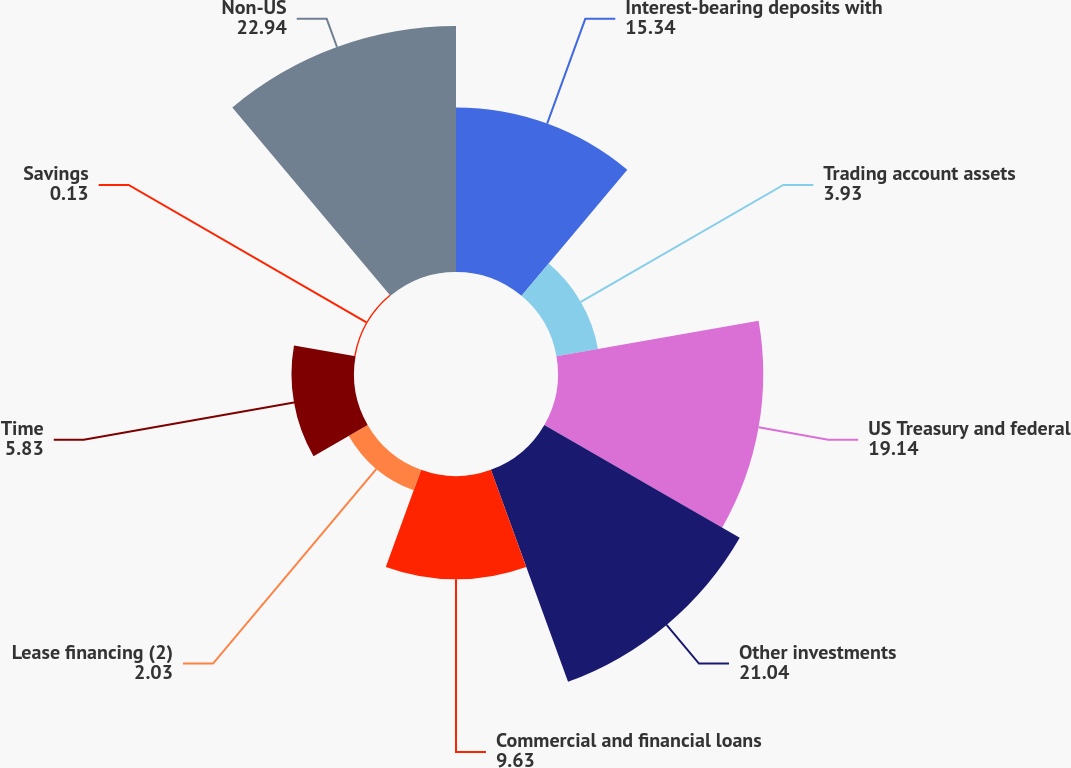Convert chart. <chart><loc_0><loc_0><loc_500><loc_500><pie_chart><fcel>Interest-bearing deposits with<fcel>Trading account assets<fcel>US Treasury and federal<fcel>Other investments<fcel>Commercial and financial loans<fcel>Lease financing (2)<fcel>Time<fcel>Savings<fcel>Non-US<nl><fcel>15.34%<fcel>3.93%<fcel>19.14%<fcel>21.04%<fcel>9.63%<fcel>2.03%<fcel>5.83%<fcel>0.13%<fcel>22.94%<nl></chart> 